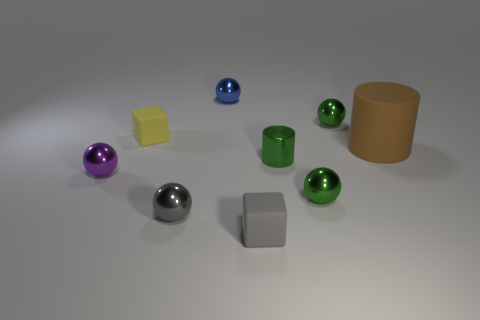There is a gray rubber object; what shape is it?
Give a very brief answer. Cube. There is a cylinder that is on the left side of the green thing behind the tiny matte object left of the tiny blue shiny object; what is it made of?
Give a very brief answer. Metal. How many other things are the same material as the purple sphere?
Offer a very short reply. 5. How many tiny objects are to the right of the tiny rubber block on the right side of the gray ball?
Offer a terse response. 3. How many cylinders are tiny yellow rubber objects or small gray shiny objects?
Provide a succinct answer. 0. There is a thing that is both to the right of the purple object and to the left of the gray metal sphere; what color is it?
Provide a short and direct response. Yellow. Is there any other thing that has the same color as the big object?
Offer a terse response. No. There is a cylinder left of the cylinder right of the green cylinder; what is its color?
Offer a terse response. Green. Is the size of the yellow cube the same as the purple ball?
Offer a very short reply. Yes. Is the small yellow thing that is to the left of the shiny cylinder made of the same material as the ball left of the tiny yellow matte thing?
Offer a terse response. No. 